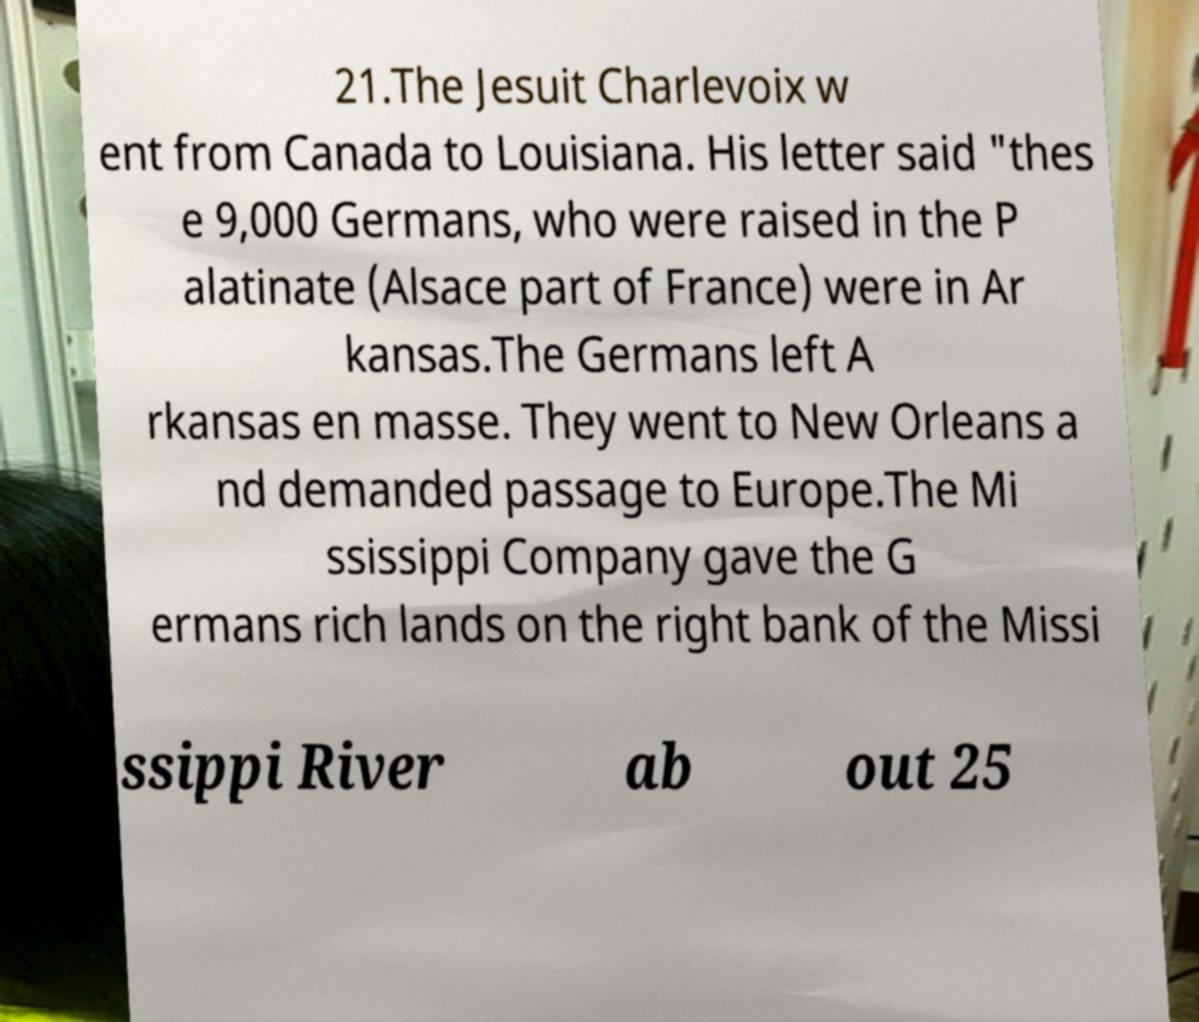Can you read and provide the text displayed in the image?This photo seems to have some interesting text. Can you extract and type it out for me? 21.The Jesuit Charlevoix w ent from Canada to Louisiana. His letter said "thes e 9,000 Germans, who were raised in the P alatinate (Alsace part of France) were in Ar kansas.The Germans left A rkansas en masse. They went to New Orleans a nd demanded passage to Europe.The Mi ssissippi Company gave the G ermans rich lands on the right bank of the Missi ssippi River ab out 25 